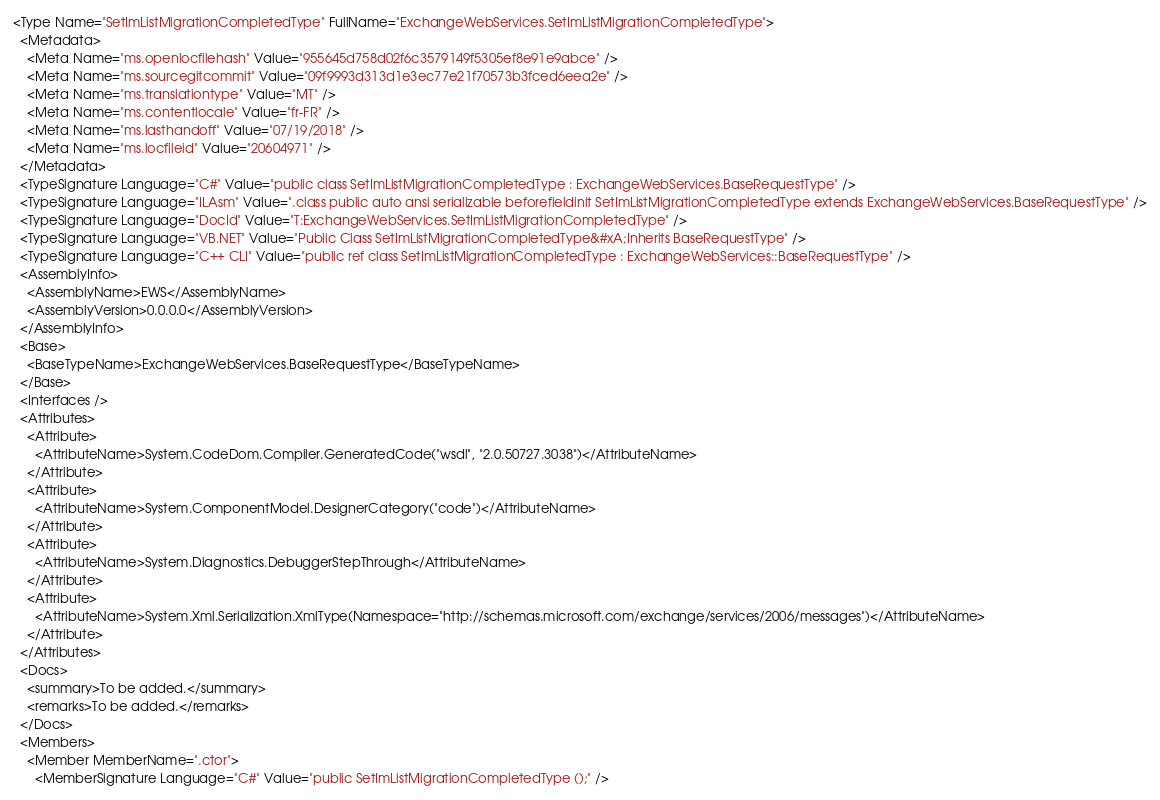<code> <loc_0><loc_0><loc_500><loc_500><_XML_><Type Name="SetImListMigrationCompletedType" FullName="ExchangeWebServices.SetImListMigrationCompletedType">
  <Metadata>
    <Meta Name="ms.openlocfilehash" Value="955645d758d02f6c3579149f5305ef8e91e9abce" />
    <Meta Name="ms.sourcegitcommit" Value="09f9993d313d1e3ec77e21f70573b3fced6eea2e" />
    <Meta Name="ms.translationtype" Value="MT" />
    <Meta Name="ms.contentlocale" Value="fr-FR" />
    <Meta Name="ms.lasthandoff" Value="07/19/2018" />
    <Meta Name="ms.locfileid" Value="20604971" />
  </Metadata>
  <TypeSignature Language="C#" Value="public class SetImListMigrationCompletedType : ExchangeWebServices.BaseRequestType" />
  <TypeSignature Language="ILAsm" Value=".class public auto ansi serializable beforefieldinit SetImListMigrationCompletedType extends ExchangeWebServices.BaseRequestType" />
  <TypeSignature Language="DocId" Value="T:ExchangeWebServices.SetImListMigrationCompletedType" />
  <TypeSignature Language="VB.NET" Value="Public Class SetImListMigrationCompletedType&#xA;Inherits BaseRequestType" />
  <TypeSignature Language="C++ CLI" Value="public ref class SetImListMigrationCompletedType : ExchangeWebServices::BaseRequestType" />
  <AssemblyInfo>
    <AssemblyName>EWS</AssemblyName>
    <AssemblyVersion>0.0.0.0</AssemblyVersion>
  </AssemblyInfo>
  <Base>
    <BaseTypeName>ExchangeWebServices.BaseRequestType</BaseTypeName>
  </Base>
  <Interfaces />
  <Attributes>
    <Attribute>
      <AttributeName>System.CodeDom.Compiler.GeneratedCode("wsdl", "2.0.50727.3038")</AttributeName>
    </Attribute>
    <Attribute>
      <AttributeName>System.ComponentModel.DesignerCategory("code")</AttributeName>
    </Attribute>
    <Attribute>
      <AttributeName>System.Diagnostics.DebuggerStepThrough</AttributeName>
    </Attribute>
    <Attribute>
      <AttributeName>System.Xml.Serialization.XmlType(Namespace="http://schemas.microsoft.com/exchange/services/2006/messages")</AttributeName>
    </Attribute>
  </Attributes>
  <Docs>
    <summary>To be added.</summary>
    <remarks>To be added.</remarks>
  </Docs>
  <Members>
    <Member MemberName=".ctor">
      <MemberSignature Language="C#" Value="public SetImListMigrationCompletedType ();" /></code> 